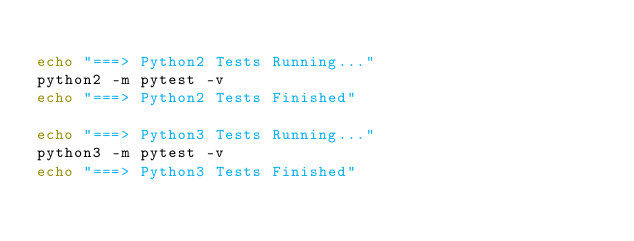<code> <loc_0><loc_0><loc_500><loc_500><_Bash_>
echo "===> Python2 Tests Running..."
python2 -m pytest -v
echo "===> Python2 Tests Finished"

echo "===> Python3 Tests Running..."
python3 -m pytest -v
echo "===> Python3 Tests Finished"
</code> 